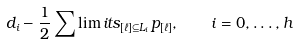Convert formula to latex. <formula><loc_0><loc_0><loc_500><loc_500>d _ { i } - \frac { 1 } { 2 } \sum \lim i t s _ { [ \ell ] \subseteq L _ { i } } p _ { [ \ell ] } , \quad i = 0 , \dots , h</formula> 